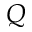Convert formula to latex. <formula><loc_0><loc_0><loc_500><loc_500>Q</formula> 